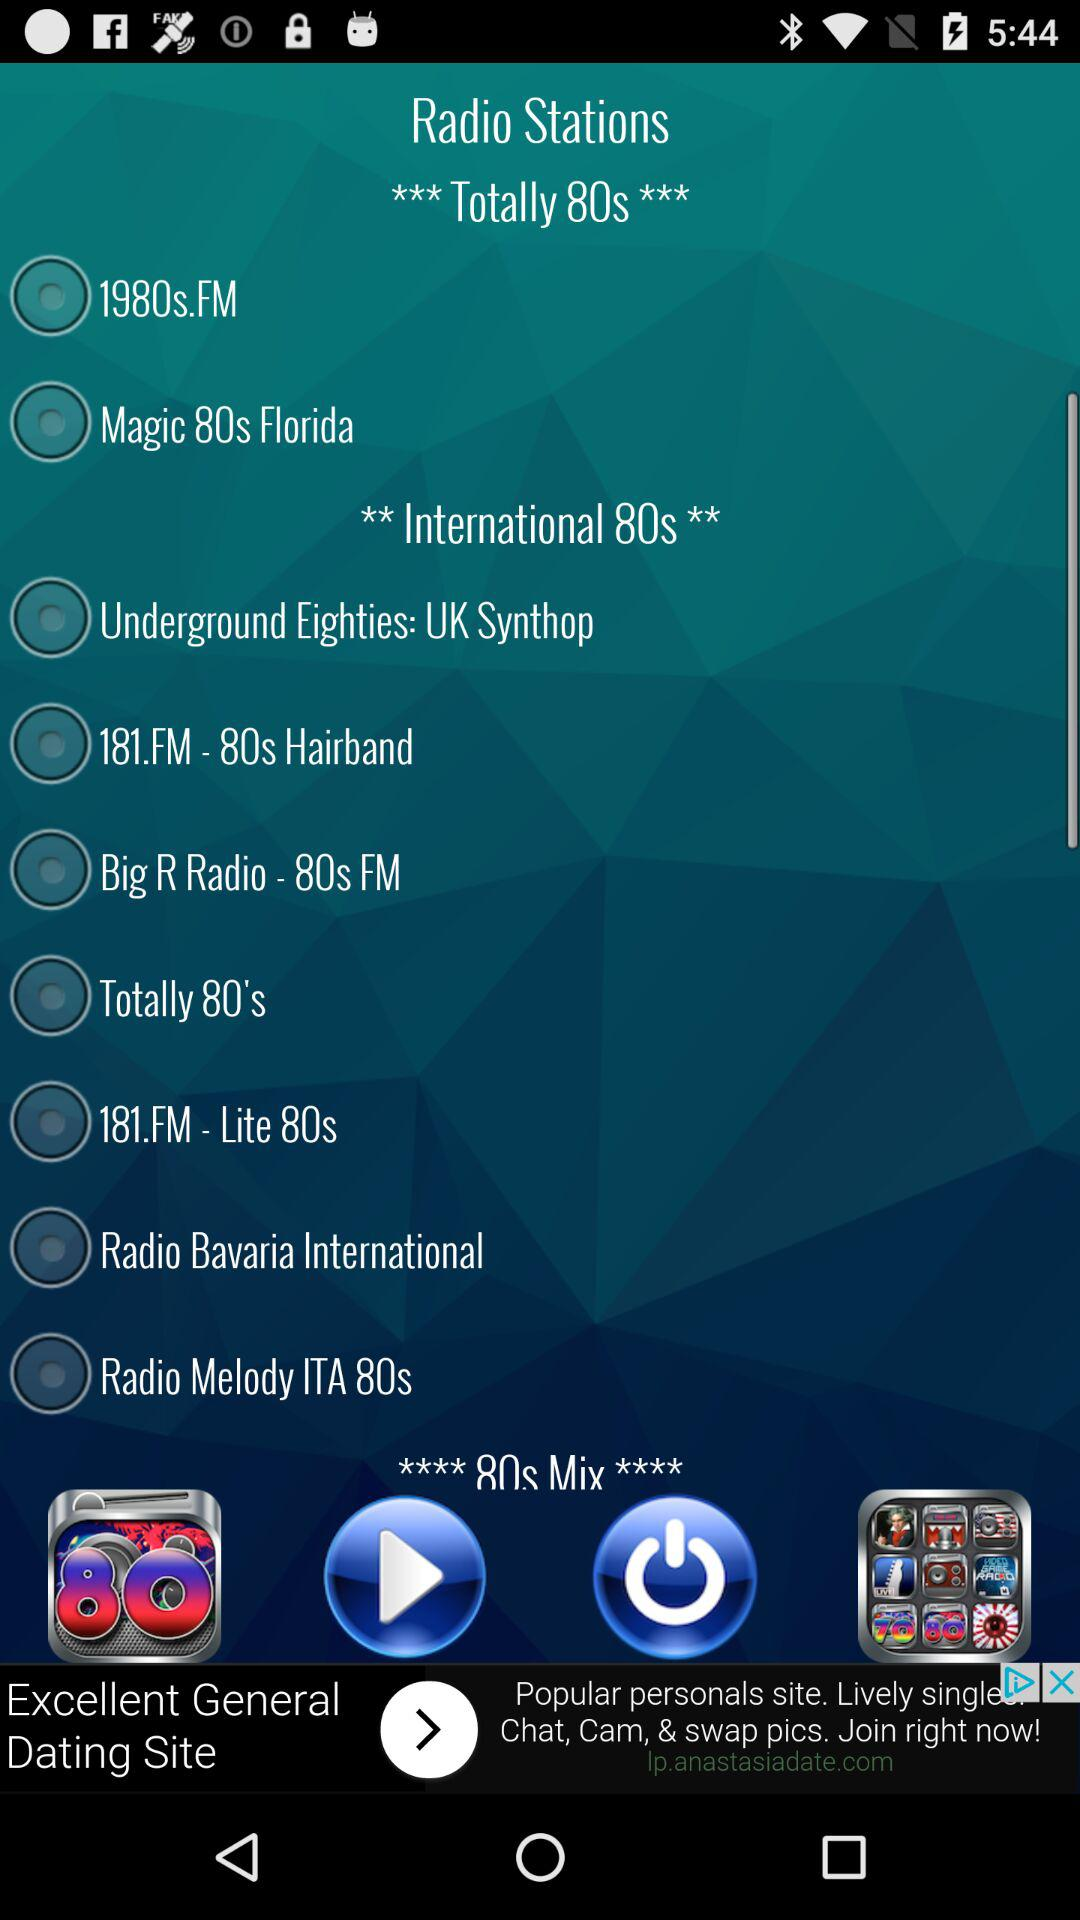What are the various international 80s radio stations? The various international 80s radio stations are "Underground Eighties: UK Synthop", "181.FM - 80s Hairband", "Big R Radio - 80s FM", "Totally 80's" and "181.FM - Lite 80s". 